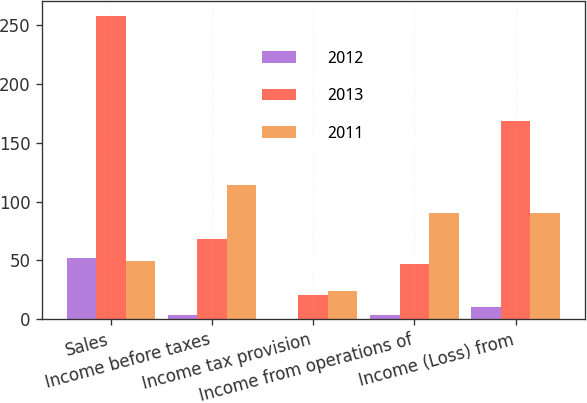<chart> <loc_0><loc_0><loc_500><loc_500><stacked_bar_chart><ecel><fcel>Sales<fcel>Income before taxes<fcel>Income tax provision<fcel>Income from operations of<fcel>Income (Loss) from<nl><fcel>2012<fcel>52.3<fcel>3.8<fcel>0.2<fcel>3.6<fcel>10<nl><fcel>2013<fcel>258<fcel>68.1<fcel>20.8<fcel>47.3<fcel>168.1<nl><fcel>2011<fcel>49.8<fcel>114.1<fcel>24.2<fcel>89.9<fcel>89.9<nl></chart> 